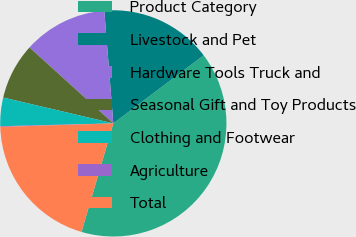Convert chart to OTSL. <chart><loc_0><loc_0><loc_500><loc_500><pie_chart><fcel>Product Category<fcel>Livestock and Pet<fcel>Hardware Tools Truck and<fcel>Seasonal Gift and Toy Products<fcel>Clothing and Footwear<fcel>Agriculture<fcel>Total<nl><fcel>39.82%<fcel>15.99%<fcel>12.02%<fcel>8.04%<fcel>4.07%<fcel>0.1%<fcel>19.96%<nl></chart> 